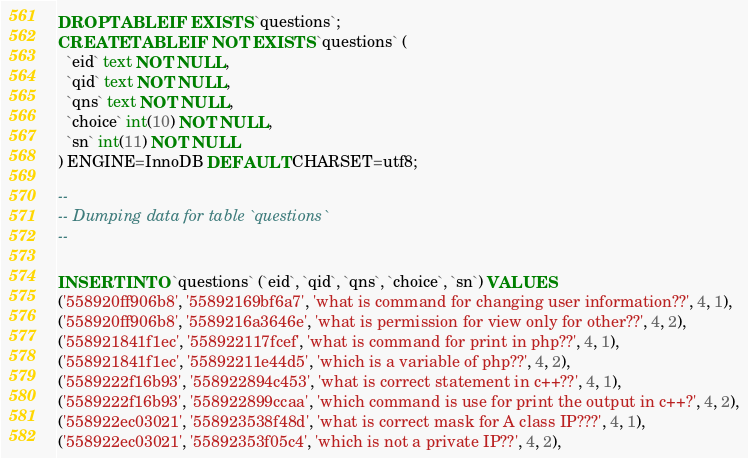Convert code to text. <code><loc_0><loc_0><loc_500><loc_500><_SQL_>
DROP TABLE IF EXISTS `questions`;
CREATE TABLE IF NOT EXISTS `questions` (
  `eid` text NOT NULL,
  `qid` text NOT NULL,
  `qns` text NOT NULL,
  `choice` int(10) NOT NULL,
  `sn` int(11) NOT NULL
) ENGINE=InnoDB DEFAULT CHARSET=utf8;

--
-- Dumping data for table `questions`
--

INSERT INTO `questions` (`eid`, `qid`, `qns`, `choice`, `sn`) VALUES
('558920ff906b8', '55892169bf6a7', 'what is command for changing user information??', 4, 1),
('558920ff906b8', '5589216a3646e', 'what is permission for view only for other??', 4, 2),
('558921841f1ec', '558922117fcef', 'what is command for print in php??', 4, 1),
('558921841f1ec', '55892211e44d5', 'which is a variable of php??', 4, 2),
('5589222f16b93', '558922894c453', 'what is correct statement in c++??', 4, 1),
('5589222f16b93', '558922899ccaa', 'which command is use for print the output in c++?', 4, 2),
('558922ec03021', '558923538f48d', 'what is correct mask for A class IP???', 4, 1),
('558922ec03021', '55892353f05c4', 'which is not a private IP??', 4, 2),</code> 